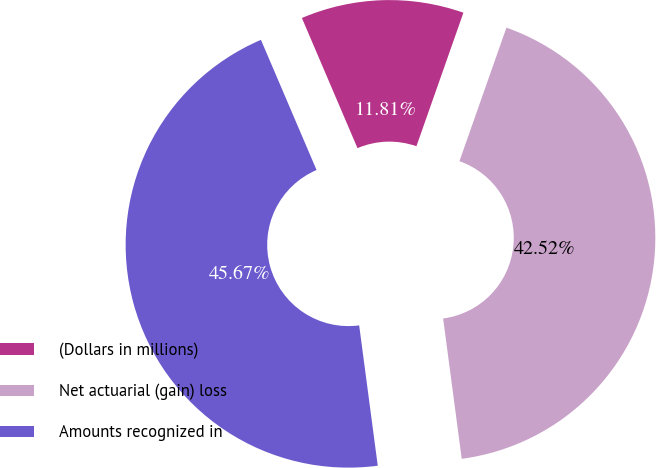<chart> <loc_0><loc_0><loc_500><loc_500><pie_chart><fcel>(Dollars in millions)<fcel>Net actuarial (gain) loss<fcel>Amounts recognized in<nl><fcel>11.81%<fcel>42.52%<fcel>45.67%<nl></chart> 